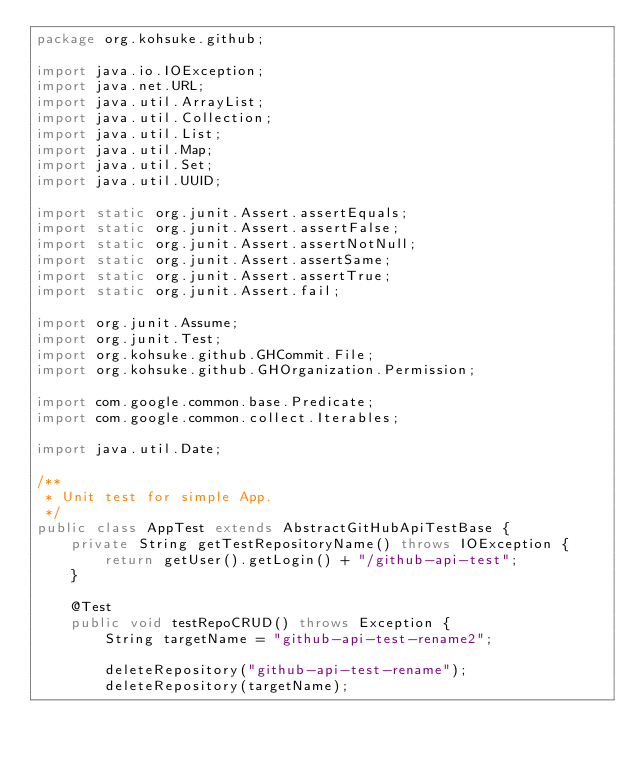<code> <loc_0><loc_0><loc_500><loc_500><_Java_>package org.kohsuke.github;

import java.io.IOException;
import java.net.URL;
import java.util.ArrayList;
import java.util.Collection;
import java.util.List;
import java.util.Map;
import java.util.Set;
import java.util.UUID;

import static org.junit.Assert.assertEquals;
import static org.junit.Assert.assertFalse;
import static org.junit.Assert.assertNotNull;
import static org.junit.Assert.assertSame;
import static org.junit.Assert.assertTrue;
import static org.junit.Assert.fail;

import org.junit.Assume;
import org.junit.Test;
import org.kohsuke.github.GHCommit.File;
import org.kohsuke.github.GHOrganization.Permission;

import com.google.common.base.Predicate;
import com.google.common.collect.Iterables;

import java.util.Date;

/**
 * Unit test for simple App.
 */
public class AppTest extends AbstractGitHubApiTestBase {
    private String getTestRepositoryName() throws IOException {
        return getUser().getLogin() + "/github-api-test";
    }

    @Test
    public void testRepoCRUD() throws Exception {
        String targetName = "github-api-test-rename2";

        deleteRepository("github-api-test-rename");
        deleteRepository(targetName);</code> 